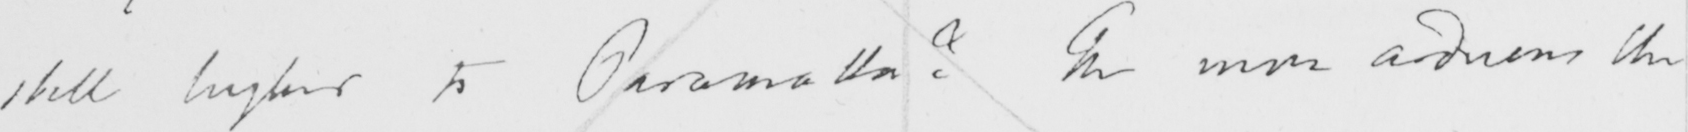What does this handwritten line say? still higher to Paramatta ?  The more arduous the 